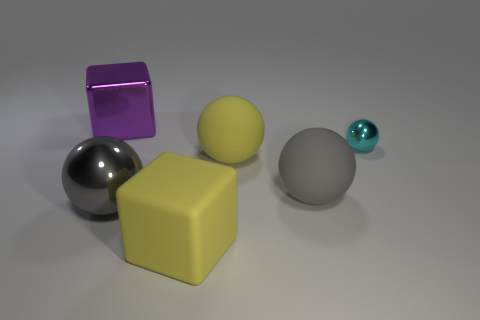Subtract 2 spheres. How many spheres are left? 2 Add 2 purple cubes. How many objects exist? 8 Subtract all cubes. How many objects are left? 4 Add 6 big shiny balls. How many big shiny balls are left? 7 Add 4 gray matte spheres. How many gray matte spheres exist? 5 Subtract 0 cyan cylinders. How many objects are left? 6 Subtract all metallic objects. Subtract all big gray metal objects. How many objects are left? 2 